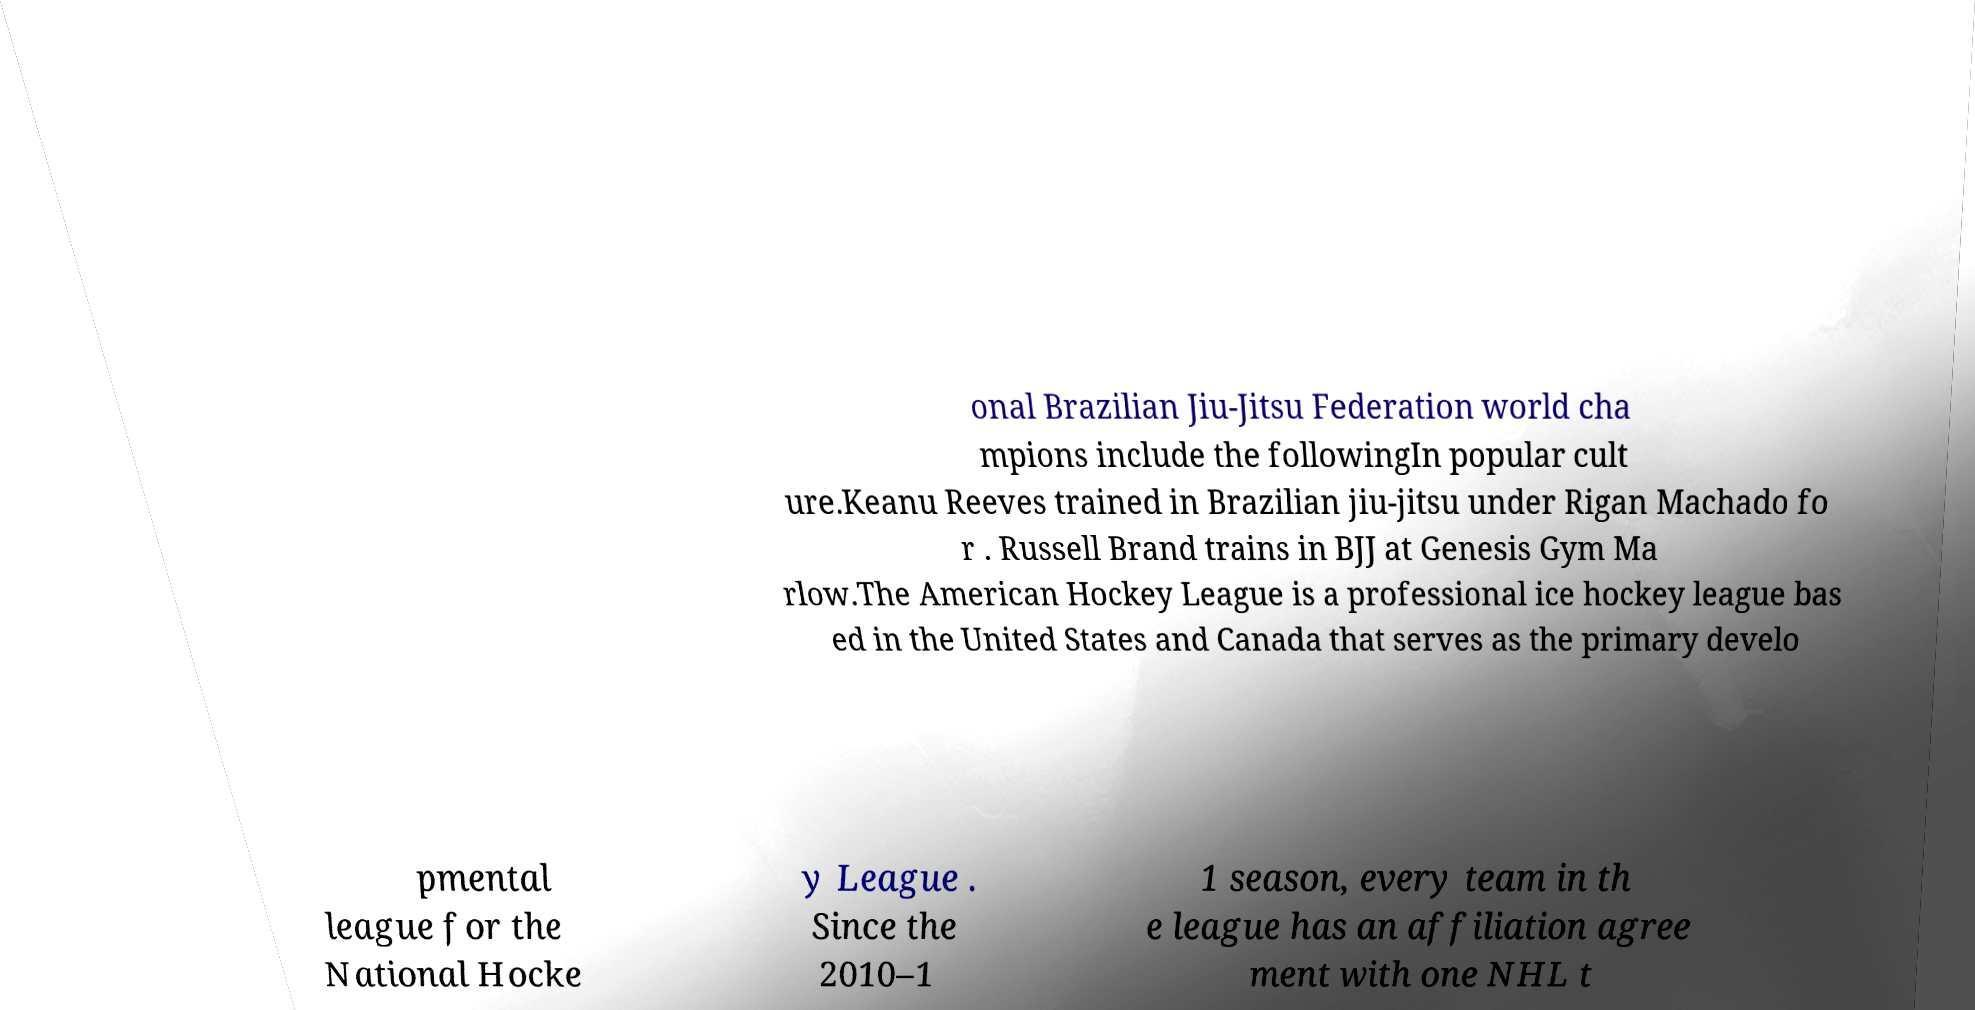There's text embedded in this image that I need extracted. Can you transcribe it verbatim? onal Brazilian Jiu-Jitsu Federation world cha mpions include the followingIn popular cult ure.Keanu Reeves trained in Brazilian jiu-jitsu under Rigan Machado fo r . Russell Brand trains in BJJ at Genesis Gym Ma rlow.The American Hockey League is a professional ice hockey league bas ed in the United States and Canada that serves as the primary develo pmental league for the National Hocke y League . Since the 2010–1 1 season, every team in th e league has an affiliation agree ment with one NHL t 